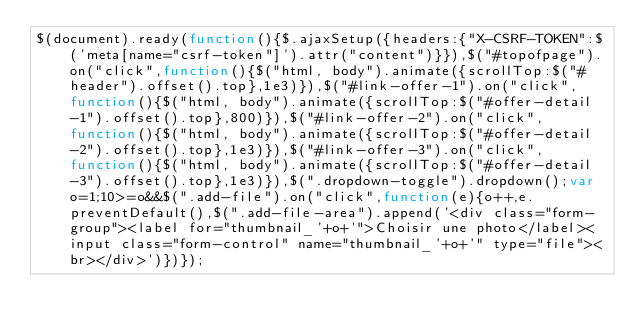<code> <loc_0><loc_0><loc_500><loc_500><_JavaScript_>$(document).ready(function(){$.ajaxSetup({headers:{"X-CSRF-TOKEN":$('meta[name="csrf-token"]').attr("content")}}),$("#topofpage").on("click",function(){$("html, body").animate({scrollTop:$("#header").offset().top},1e3)}),$("#link-offer-1").on("click",function(){$("html, body").animate({scrollTop:$("#offer-detail-1").offset().top},800)}),$("#link-offer-2").on("click",function(){$("html, body").animate({scrollTop:$("#offer-detail-2").offset().top},1e3)}),$("#link-offer-3").on("click",function(){$("html, body").animate({scrollTop:$("#offer-detail-3").offset().top},1e3)}),$(".dropdown-toggle").dropdown();var o=1;10>=o&&$(".add-file").on("click",function(e){o++,e.preventDefault(),$(".add-file-area").append('<div class="form-group"><label for="thumbnail_'+o+'">Choisir une photo</label><input class="form-control" name="thumbnail_'+o+'" type="file"><br></div>')})});</code> 